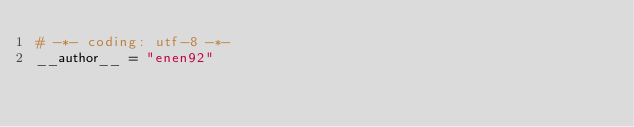Convert code to text. <code><loc_0><loc_0><loc_500><loc_500><_Python_># -*- coding: utf-8 -*-
__author__ = "enen92"
</code> 